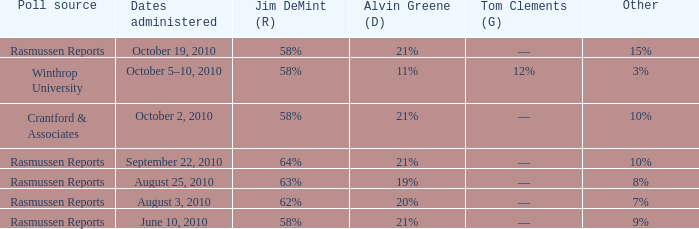Which poll source determined undecided of 5% and Jim DeMint (R) of 58%? Crantford & Associates. 